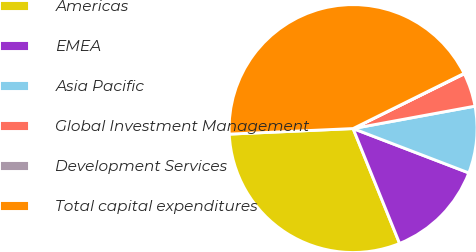Convert chart. <chart><loc_0><loc_0><loc_500><loc_500><pie_chart><fcel>Americas<fcel>EMEA<fcel>Asia Pacific<fcel>Global Investment Management<fcel>Development Services<fcel>Total capital expenditures<nl><fcel>30.41%<fcel>13.05%<fcel>8.72%<fcel>4.39%<fcel>0.06%<fcel>43.37%<nl></chart> 